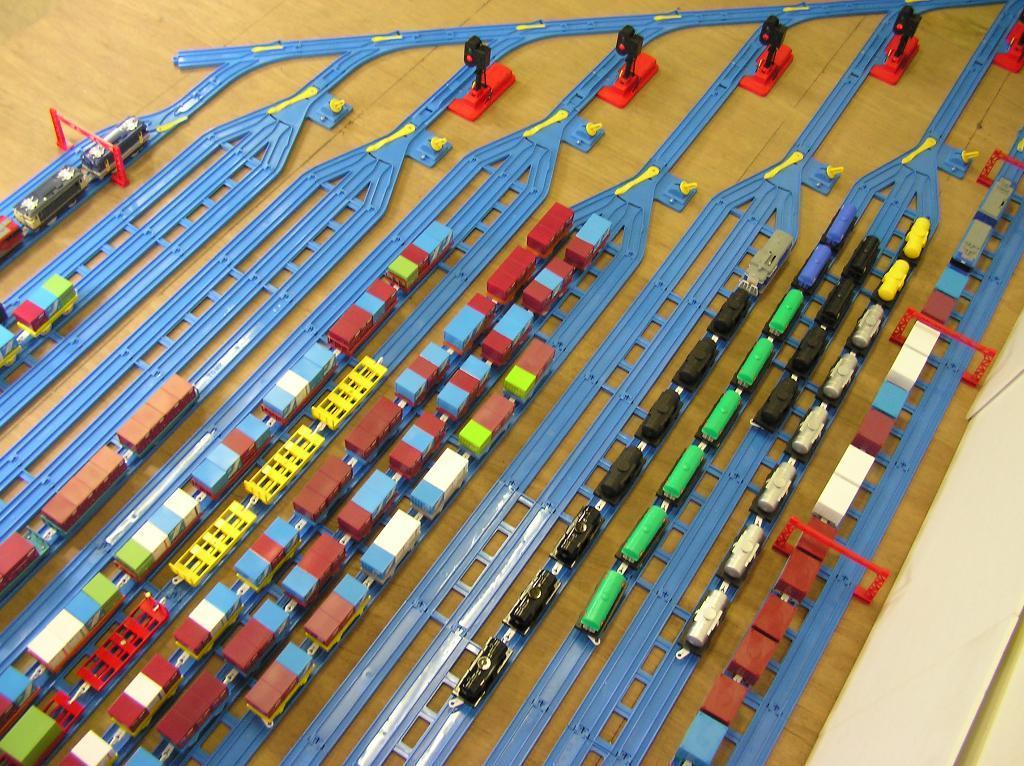How would you summarize this image in a sentence or two? In this image, we can see some toys like trains, tracks and poles on the surface. 